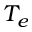Convert formula to latex. <formula><loc_0><loc_0><loc_500><loc_500>T _ { e }</formula> 